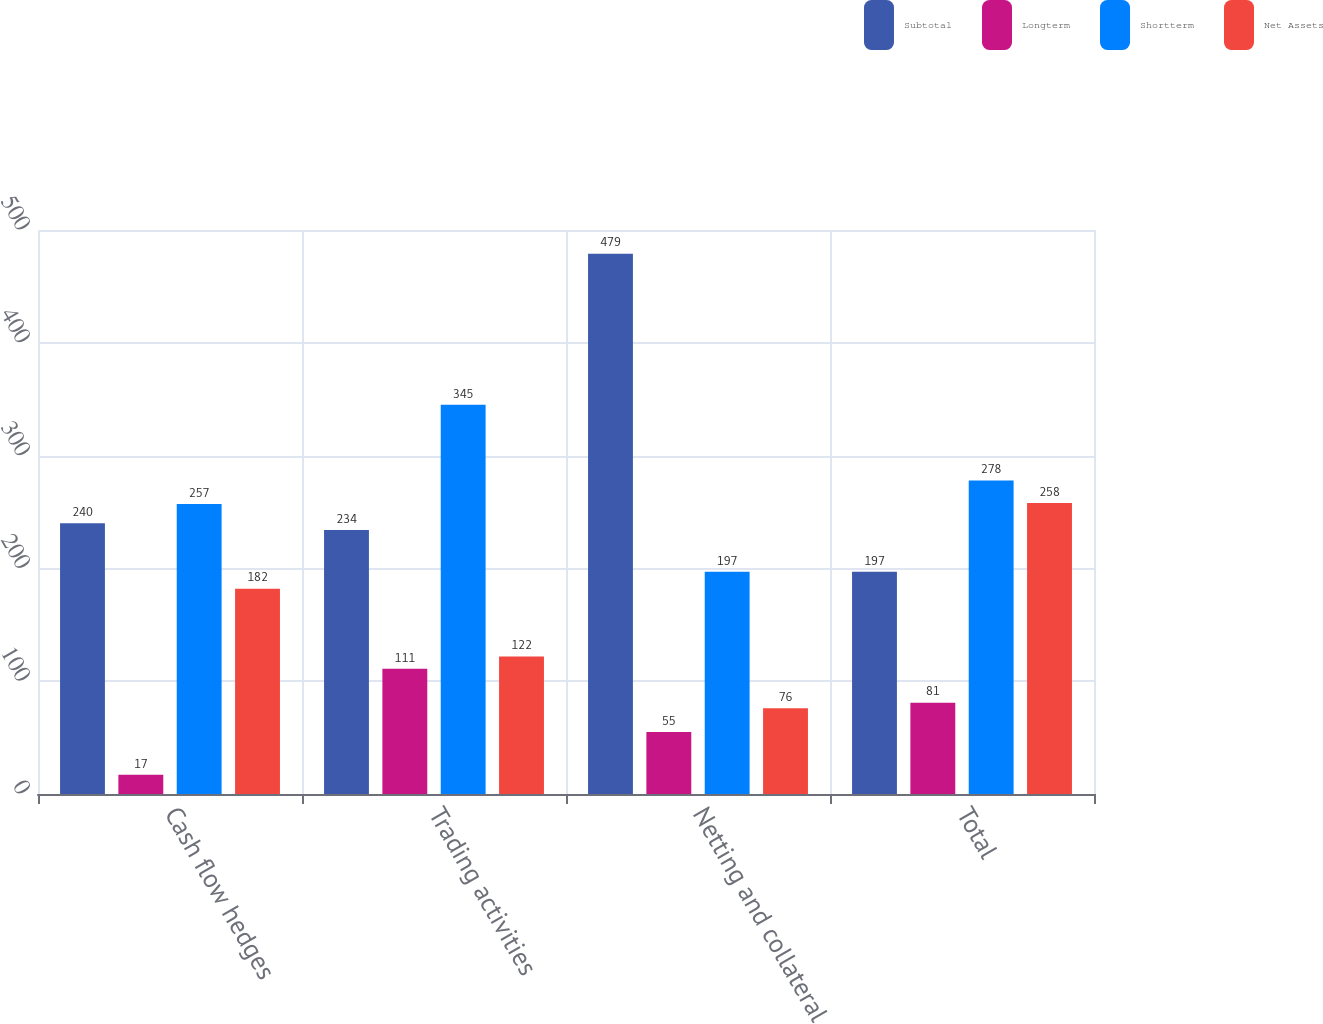Convert chart to OTSL. <chart><loc_0><loc_0><loc_500><loc_500><stacked_bar_chart><ecel><fcel>Cash flow hedges<fcel>Trading activities<fcel>Netting and collateral<fcel>Total<nl><fcel>Subtotal<fcel>240<fcel>234<fcel>479<fcel>197<nl><fcel>Longterm<fcel>17<fcel>111<fcel>55<fcel>81<nl><fcel>Shortterm<fcel>257<fcel>345<fcel>197<fcel>278<nl><fcel>Net Assets<fcel>182<fcel>122<fcel>76<fcel>258<nl></chart> 